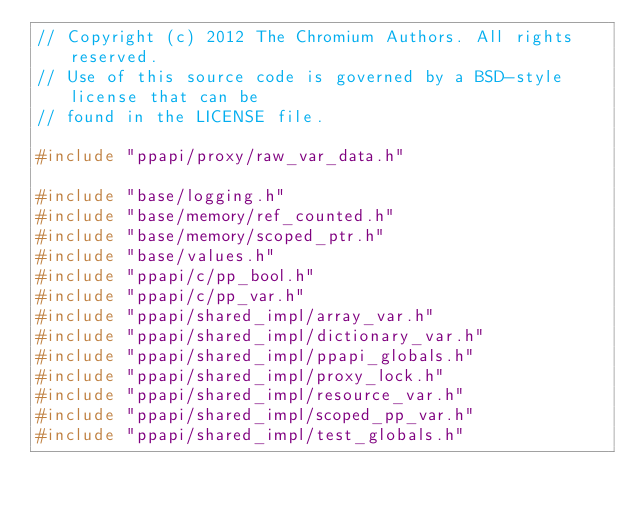<code> <loc_0><loc_0><loc_500><loc_500><_C++_>// Copyright (c) 2012 The Chromium Authors. All rights reserved.
// Use of this source code is governed by a BSD-style license that can be
// found in the LICENSE file.

#include "ppapi/proxy/raw_var_data.h"

#include "base/logging.h"
#include "base/memory/ref_counted.h"
#include "base/memory/scoped_ptr.h"
#include "base/values.h"
#include "ppapi/c/pp_bool.h"
#include "ppapi/c/pp_var.h"
#include "ppapi/shared_impl/array_var.h"
#include "ppapi/shared_impl/dictionary_var.h"
#include "ppapi/shared_impl/ppapi_globals.h"
#include "ppapi/shared_impl/proxy_lock.h"
#include "ppapi/shared_impl/resource_var.h"
#include "ppapi/shared_impl/scoped_pp_var.h"
#include "ppapi/shared_impl/test_globals.h"</code> 